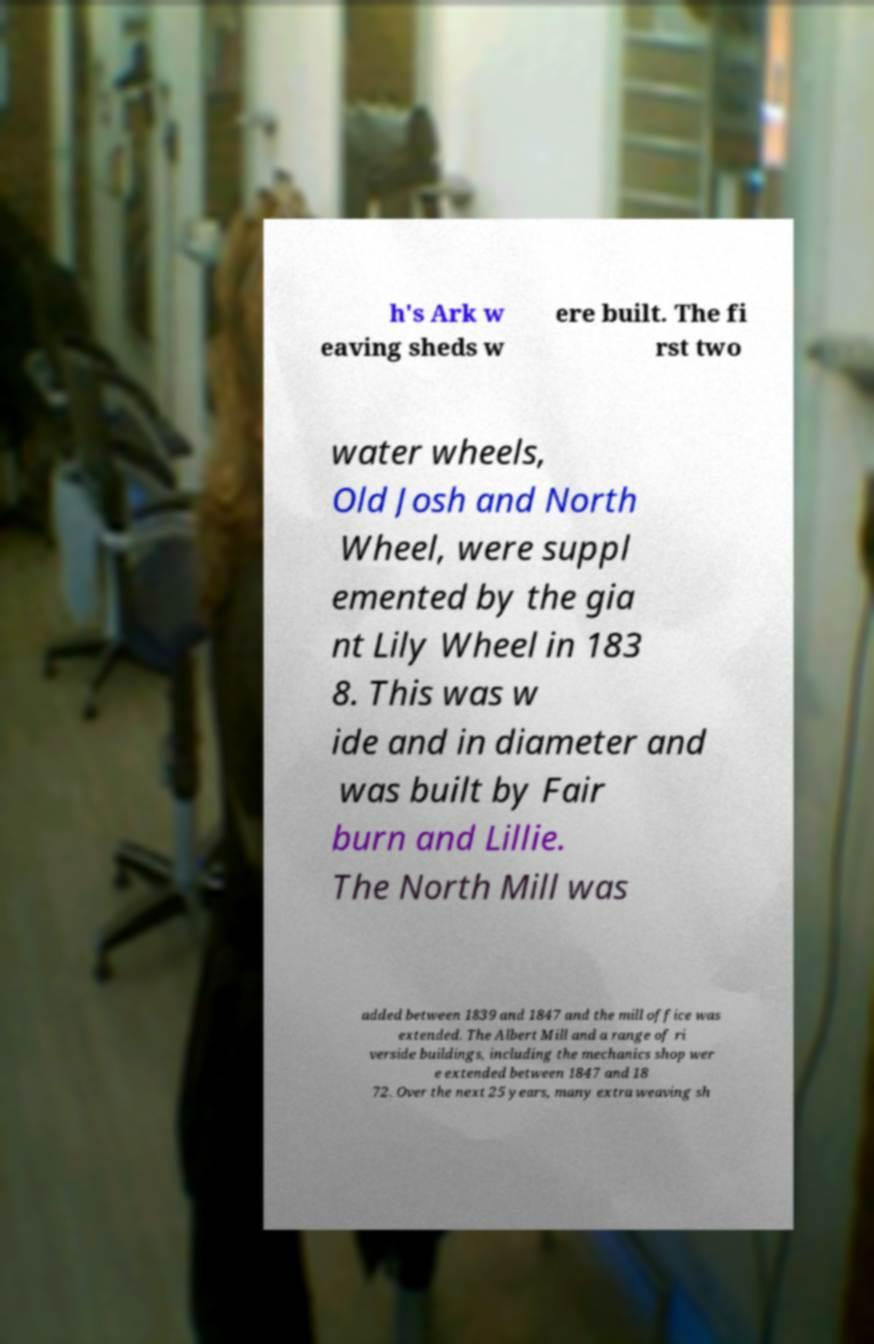What messages or text are displayed in this image? I need them in a readable, typed format. h's Ark w eaving sheds w ere built. The fi rst two water wheels, Old Josh and North Wheel, were suppl emented by the gia nt Lily Wheel in 183 8. This was w ide and in diameter and was built by Fair burn and Lillie. The North Mill was added between 1839 and 1847 and the mill office was extended. The Albert Mill and a range of ri verside buildings, including the mechanics shop wer e extended between 1847 and 18 72. Over the next 25 years, many extra weaving sh 